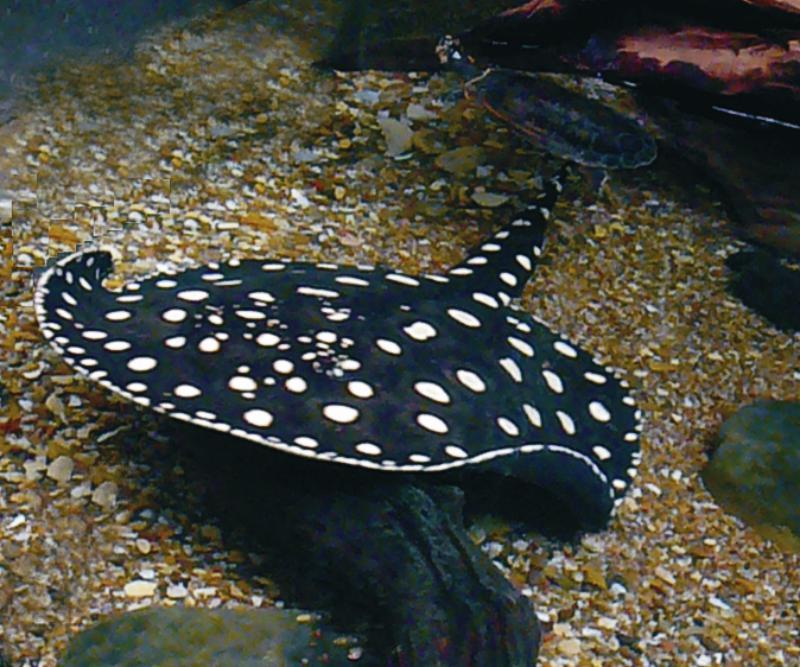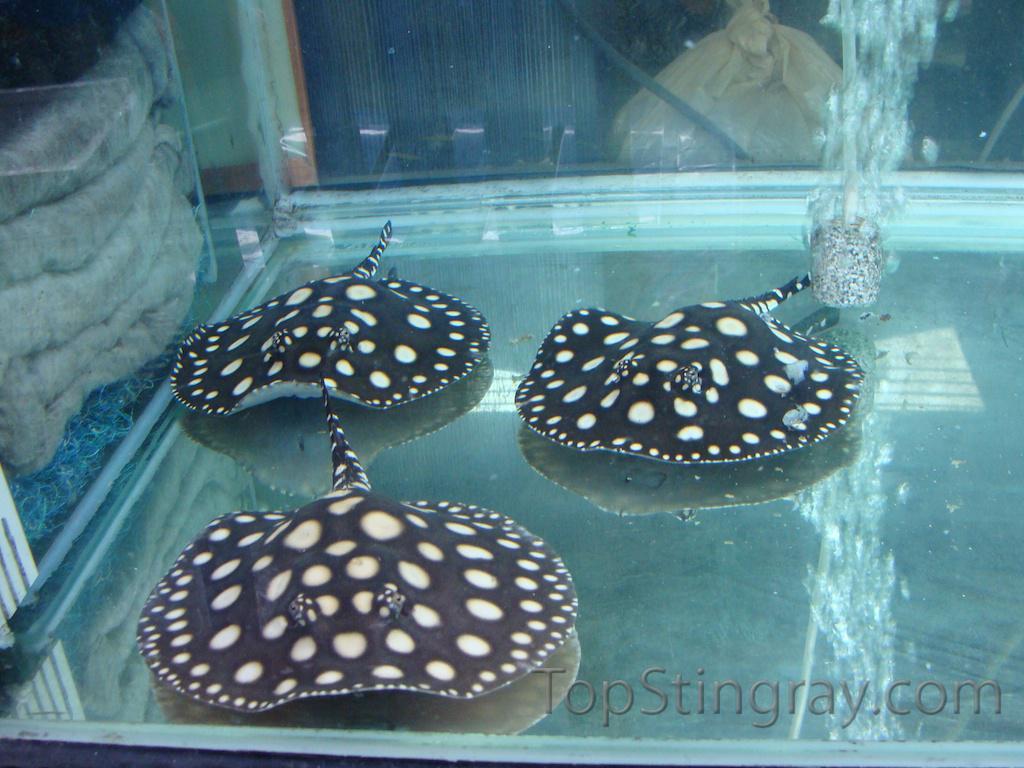The first image is the image on the left, the second image is the image on the right. For the images displayed, is the sentence "There are at least 2 black stingrays with white spots." factually correct? Answer yes or no. Yes. The first image is the image on the left, the second image is the image on the right. Assess this claim about the two images: "There are two stingrays.". Correct or not? Answer yes or no. No. 